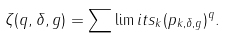Convert formula to latex. <formula><loc_0><loc_0><loc_500><loc_500>\zeta ( q , \delta , g ) = \sum \lim i t s _ { k } ( p _ { k , \delta , g } ) ^ { q } .</formula> 